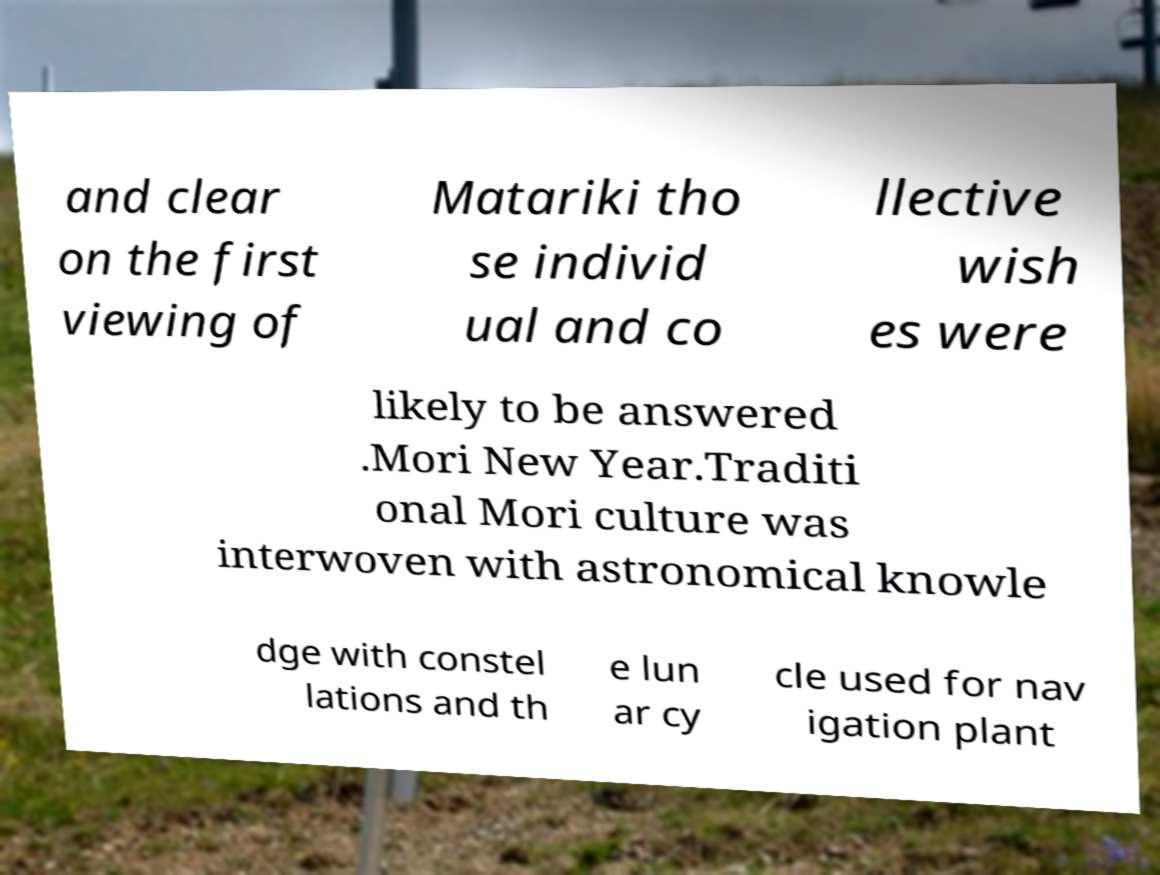Please read and relay the text visible in this image. What does it say? and clear on the first viewing of Matariki tho se individ ual and co llective wish es were likely to be answered .Mori New Year.Traditi onal Mori culture was interwoven with astronomical knowle dge with constel lations and th e lun ar cy cle used for nav igation plant 